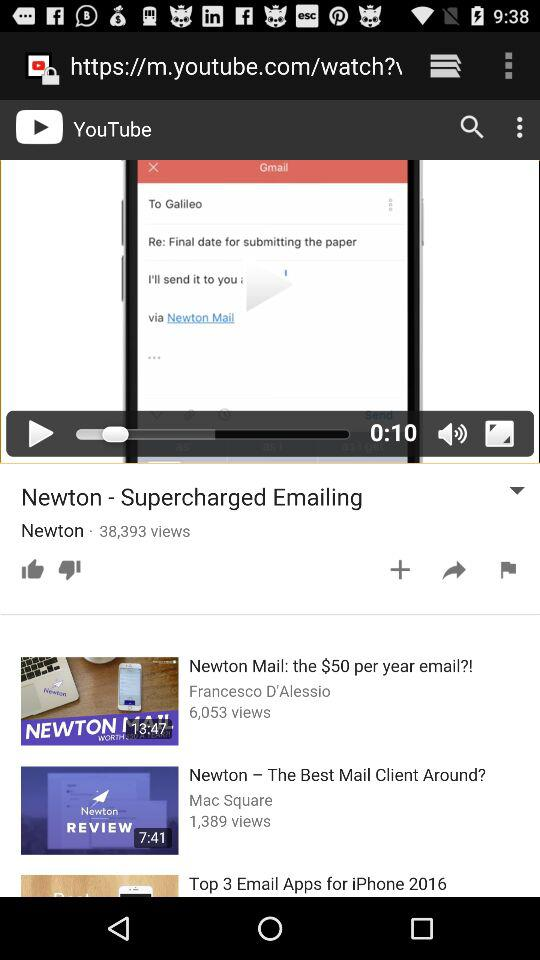How many views are there of "Newton – The Best Mail Client Around"? There are 1,389 views. 